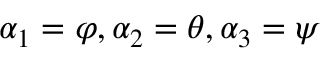<formula> <loc_0><loc_0><loc_500><loc_500>\alpha _ { 1 } = \varphi , \alpha _ { 2 } = \theta , \alpha _ { 3 } = \psi</formula> 